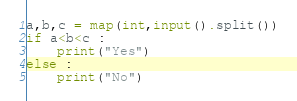<code> <loc_0><loc_0><loc_500><loc_500><_Python_>a,b,c = map(int,input().split())
if a<b<c :
    print("Yes")
else :
    print("No")

</code> 